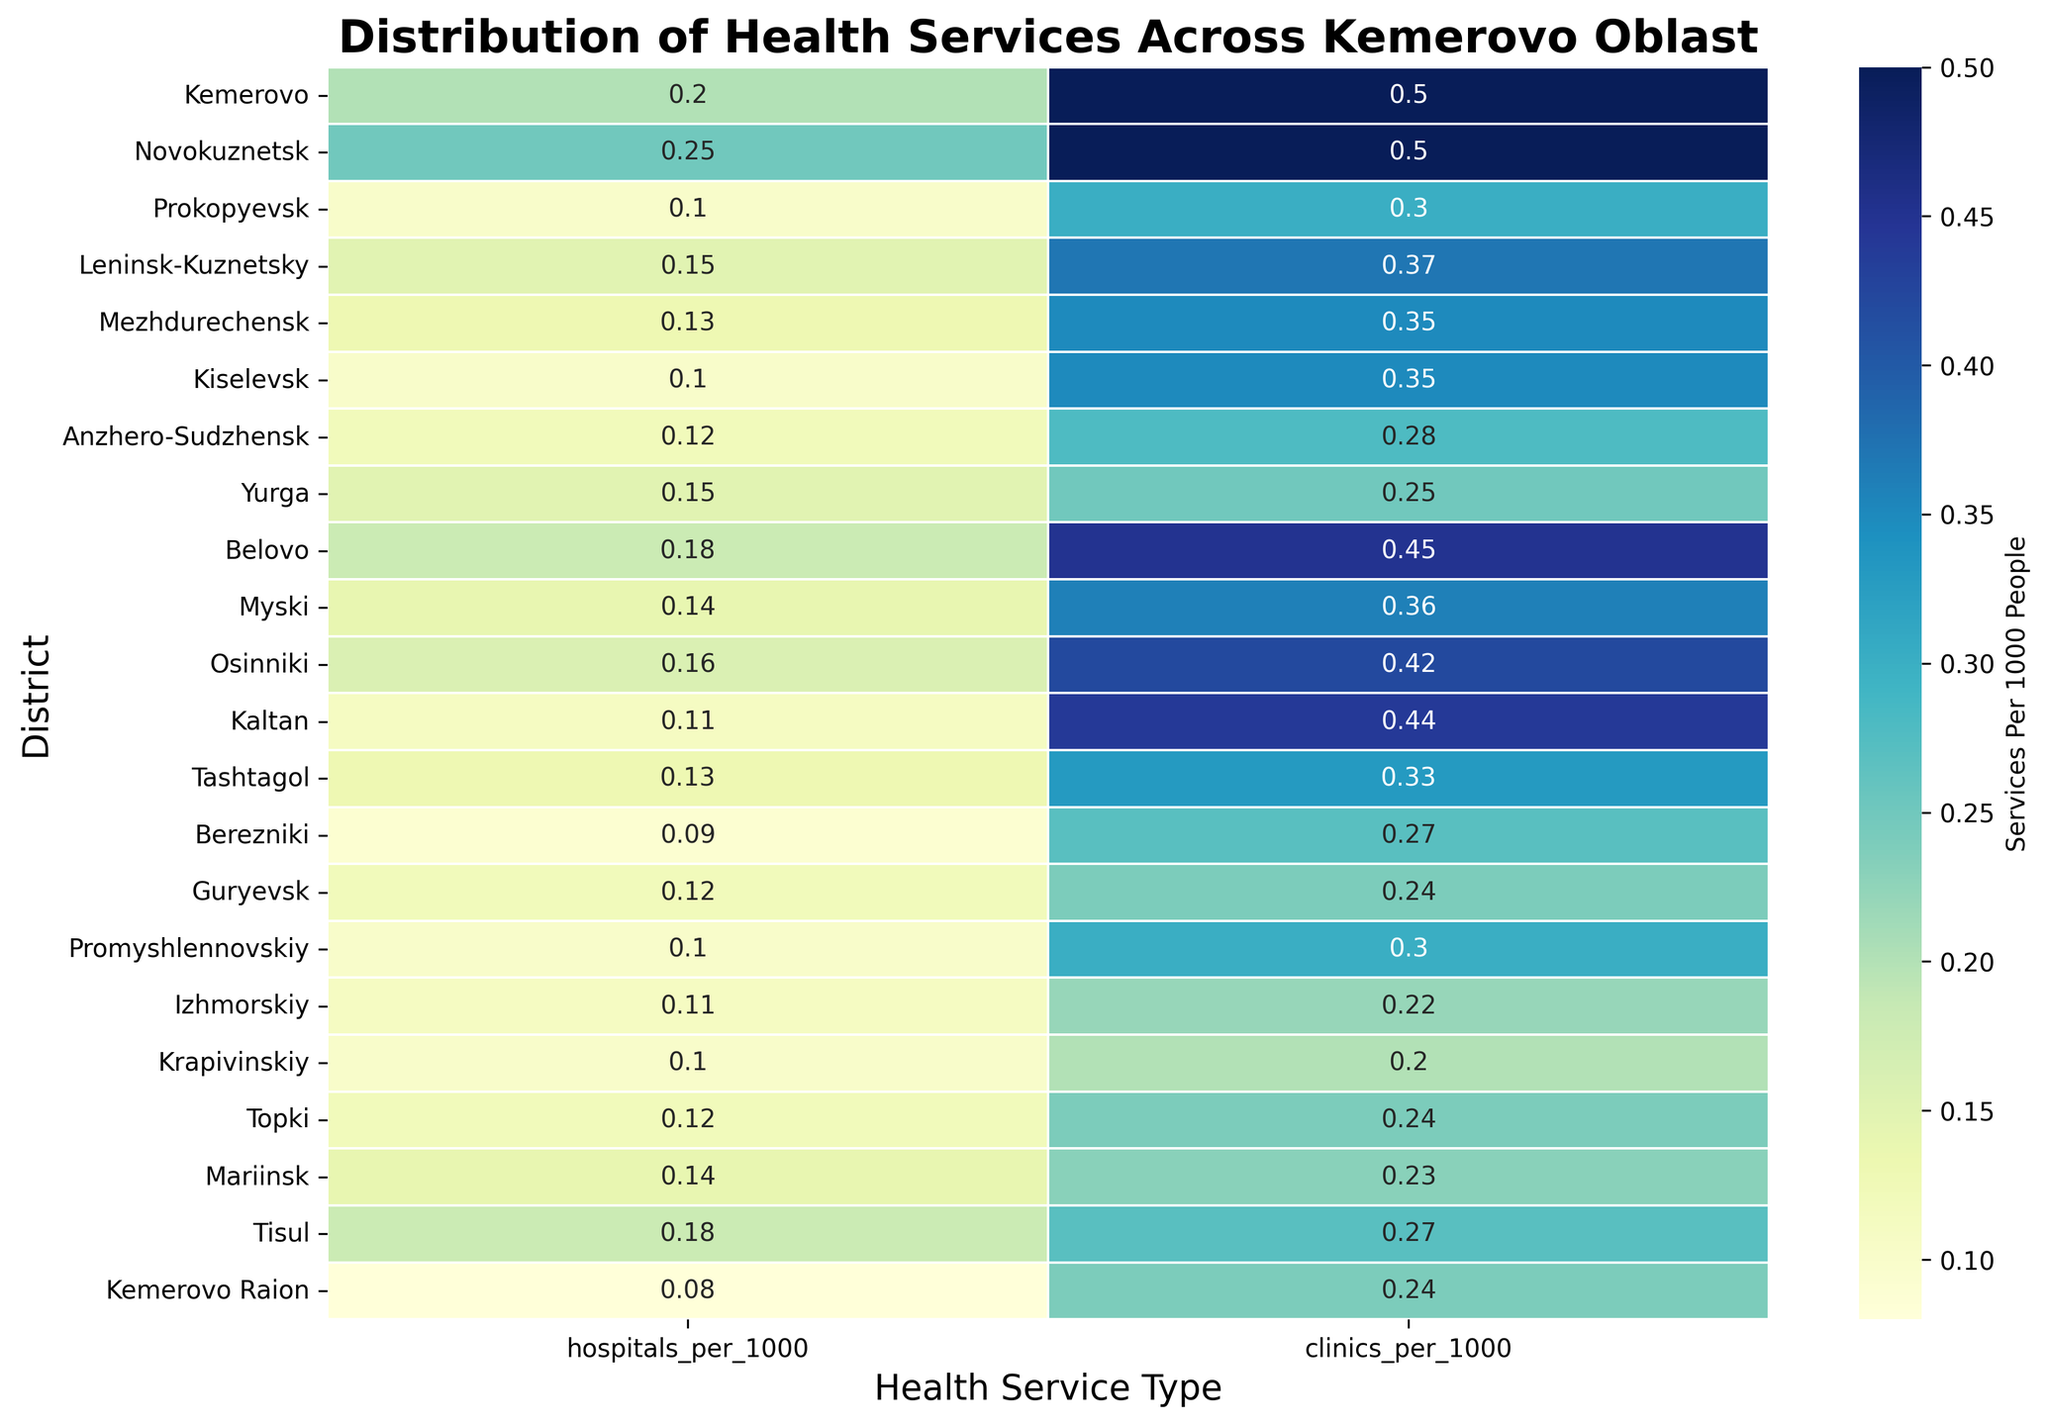What district has the highest number of hospitals per 1000 people? To find the district with the highest number of hospitals per 1000 people, you need to look at the row with the darkest color in the 'hospitals_per_1000' column.
Answer: Novokuznetsk Which district has a higher clinics per 1000 people ratio, Leninsk-Kuznetsky or Promyshlennovskiy? Compare the 'clinics_per_1000' values of Leninsk-Kuznetsky and Promyshlennovskiy. Leninsk-Kuznetsky has 0.37 clinics per 1000 people, whereas Promyshlennovskiy has 0.30.
Answer: Leninsk-Kuznetsky What is the average number of clinics per 1000 people in Kemerovo and Novokuznetsk? Add the 'clinics_per_1000' values of Kemerovo (0.50) and Novokuznetsk (0.50) and divide the sum by 2. The average is (0.50 + 0.50) / 2 = 0.50.
Answer: 0.50 Which district has the least number of hospitals per 1000 people, and what is its value? Look for the district with the lightest color in the 'hospitals_per_1000' column, which represents the minimum value. Berezniki has the lowest value at 0.09 per 1000 people.
Answer: Berezniki, 0.09 Are there more districts with hospitals per 1000 people above 0.15 or below 0.15? Count the number of districts with 'hospitals_per_1000' above and below 0.15. Those below are Prokopyevsk, Kiselevsk, Anzhero-Sudzhensk, Guryevsk, Promyshlennovskiy, Izhmorskiy, Krapivinskiy, Topki, Mariinsk, and Kemerovo Raion (10 districts). Those above are Kemerovo, Novokuznetsk, Leninsk-Kuznetsky, Mezhdurechensk, Yurga, Belovo, Osinniki, Kaltan, Tashtagol, and Tisul (10 districts).
Answer: Equal How does the number of clinics per 1000 people in Belovo compare to its hospitals per 1000 people? Belovo has 0.45 clinics per 1000 people and 0.18 hospitals per 1000 people. The number of clinics per 1000 people is greater than hospitals per 1000 people in Belovo.
Answer: Clinics per 1000 people is greater What is the combined ratio of hospitals and clinics per 1000 people in Prokopyevsk? Sum the 'hospitals_per_1000' and 'clinics_per_1000' values for Prokopyevsk. The combined ratio is 0.10 + 0.30 = 0.40 per 1000 people.
Answer: 0.40 How many districts have at least 0.40 clinics per 1000 people? Count the districts with 'clinics_per_1000' values 0.40 or greater. The districts are Kemerovo, Novokuznetsk, Leninsk-Kuznetsky, Belovo, Osinniki, and Kaltan (6 districts).
Answer: 6 Are there any districts where the number of hospitals per 1000 people is more than double the number of clinics per 1000 people? Check each district to see if 'hospitals_per_1000' is more than twice the 'clinics_per_1000'. None of the districts meet this criterion as all have less than double the number of clinics.
Answer: No 